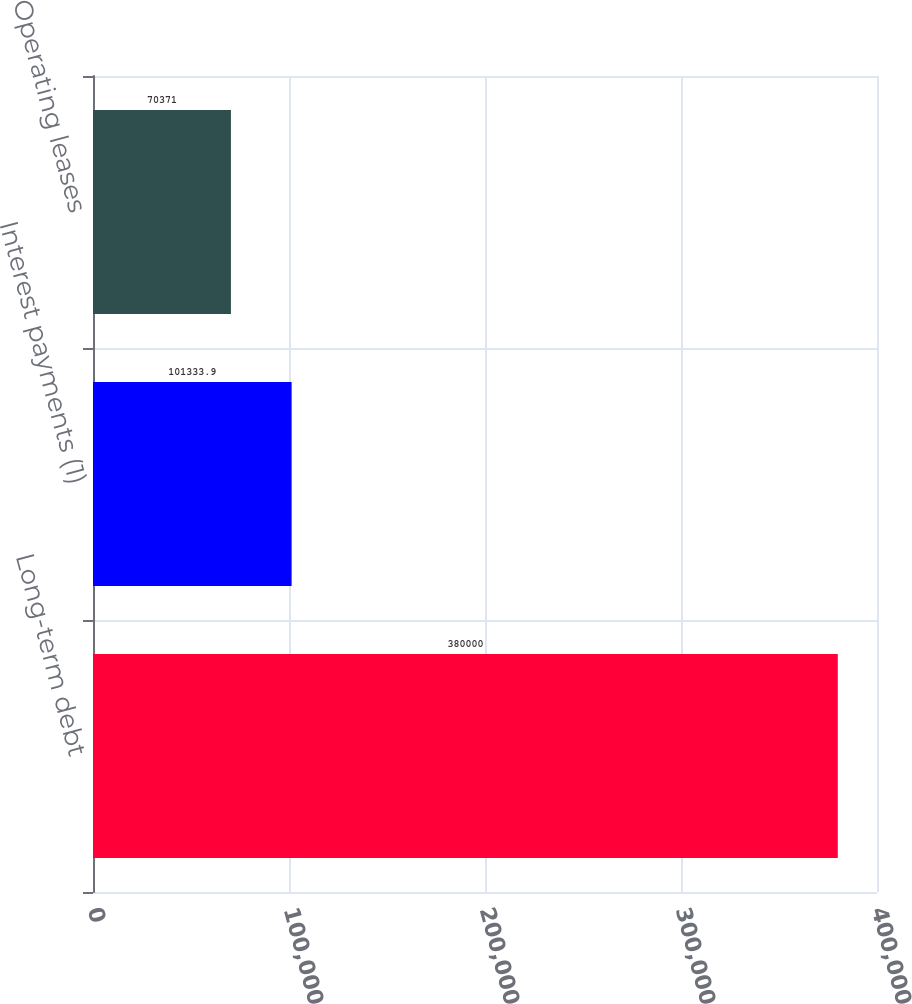Convert chart. <chart><loc_0><loc_0><loc_500><loc_500><bar_chart><fcel>Long-term debt<fcel>Interest payments (1)<fcel>Operating leases<nl><fcel>380000<fcel>101334<fcel>70371<nl></chart> 